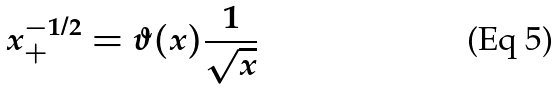Convert formula to latex. <formula><loc_0><loc_0><loc_500><loc_500>x _ { + } ^ { - 1 / 2 } = \vartheta ( x ) \frac { 1 } { \sqrt { x } }</formula> 